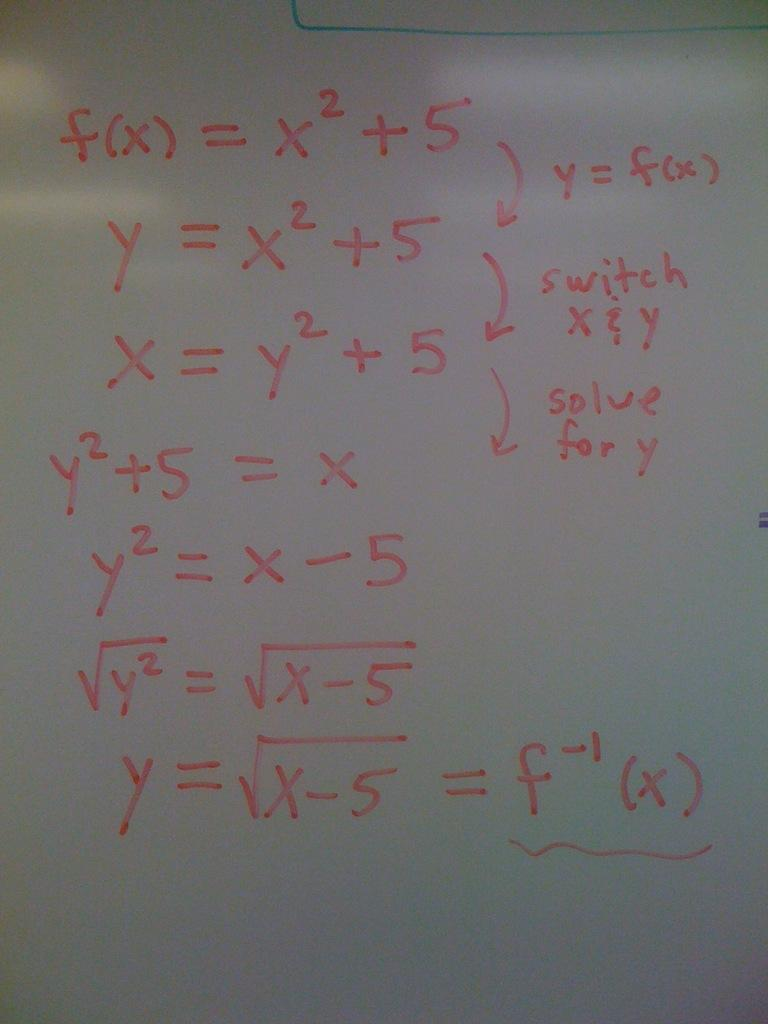<image>
Share a concise interpretation of the image provided. A white board has a math problem on it looking for the function which is noted by f(x). 